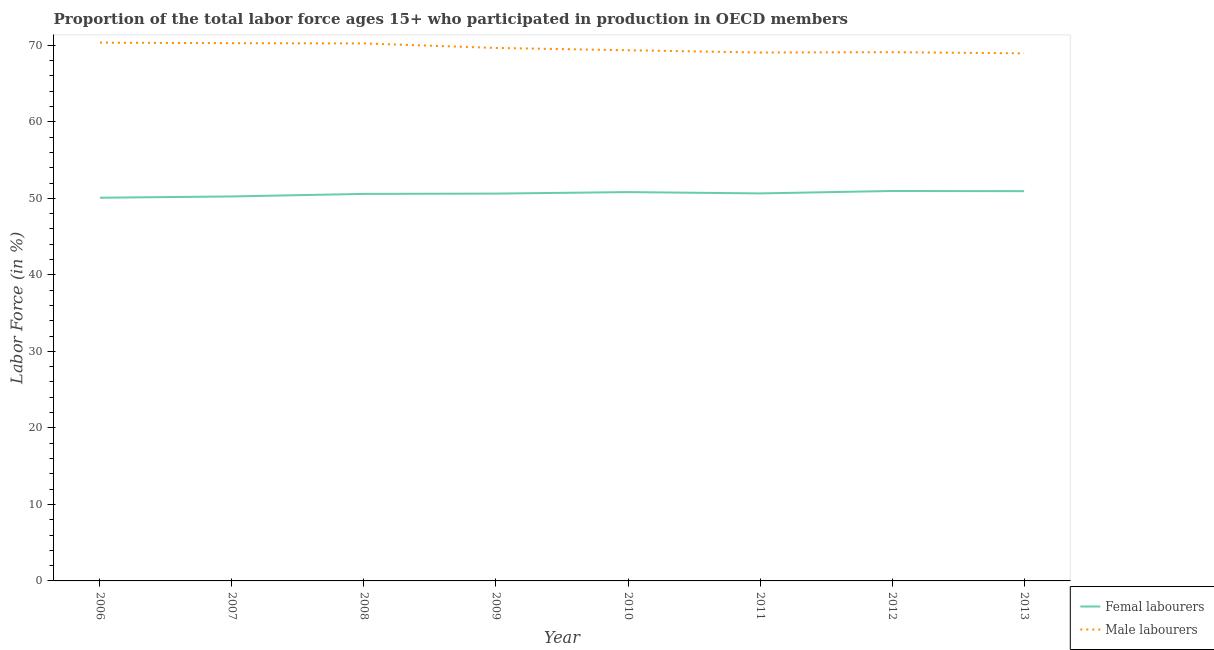How many different coloured lines are there?
Your answer should be very brief. 2. Is the number of lines equal to the number of legend labels?
Give a very brief answer. Yes. What is the percentage of female labor force in 2007?
Provide a short and direct response. 50.25. Across all years, what is the maximum percentage of male labour force?
Your answer should be compact. 70.35. Across all years, what is the minimum percentage of female labor force?
Your answer should be very brief. 50.08. In which year was the percentage of male labour force maximum?
Your answer should be compact. 2006. In which year was the percentage of female labor force minimum?
Your answer should be compact. 2006. What is the total percentage of female labor force in the graph?
Offer a terse response. 404.91. What is the difference between the percentage of male labour force in 2011 and that in 2013?
Your answer should be very brief. 0.11. What is the difference between the percentage of male labour force in 2006 and the percentage of female labor force in 2013?
Offer a terse response. 19.41. What is the average percentage of male labour force per year?
Provide a succinct answer. 69.63. In the year 2008, what is the difference between the percentage of male labour force and percentage of female labor force?
Offer a terse response. 19.67. In how many years, is the percentage of female labor force greater than 20 %?
Offer a terse response. 8. What is the ratio of the percentage of male labour force in 2006 to that in 2011?
Provide a succinct answer. 1.02. Is the percentage of female labor force in 2009 less than that in 2010?
Your response must be concise. Yes. Is the difference between the percentage of female labor force in 2006 and 2008 greater than the difference between the percentage of male labour force in 2006 and 2008?
Your answer should be very brief. No. What is the difference between the highest and the second highest percentage of female labor force?
Provide a short and direct response. 0.03. What is the difference between the highest and the lowest percentage of male labour force?
Your response must be concise. 1.4. In how many years, is the percentage of male labour force greater than the average percentage of male labour force taken over all years?
Offer a terse response. 4. Does the percentage of male labour force monotonically increase over the years?
Offer a terse response. No. Is the percentage of male labour force strictly greater than the percentage of female labor force over the years?
Offer a terse response. Yes. Is the percentage of female labor force strictly less than the percentage of male labour force over the years?
Provide a short and direct response. Yes. How many lines are there?
Keep it short and to the point. 2. How many years are there in the graph?
Offer a very short reply. 8. What is the difference between two consecutive major ticks on the Y-axis?
Give a very brief answer. 10. Are the values on the major ticks of Y-axis written in scientific E-notation?
Your answer should be compact. No. Does the graph contain grids?
Make the answer very short. No. What is the title of the graph?
Your response must be concise. Proportion of the total labor force ages 15+ who participated in production in OECD members. What is the Labor Force (in %) of Femal labourers in 2006?
Provide a short and direct response. 50.08. What is the Labor Force (in %) of Male labourers in 2006?
Your answer should be compact. 70.35. What is the Labor Force (in %) in Femal labourers in 2007?
Your answer should be compact. 50.25. What is the Labor Force (in %) in Male labourers in 2007?
Provide a succinct answer. 70.28. What is the Labor Force (in %) of Femal labourers in 2008?
Offer a very short reply. 50.58. What is the Labor Force (in %) of Male labourers in 2008?
Make the answer very short. 70.25. What is the Labor Force (in %) in Femal labourers in 2009?
Give a very brief answer. 50.62. What is the Labor Force (in %) of Male labourers in 2009?
Your answer should be compact. 69.66. What is the Labor Force (in %) of Femal labourers in 2010?
Your answer should be very brief. 50.82. What is the Labor Force (in %) in Male labourers in 2010?
Keep it short and to the point. 69.36. What is the Labor Force (in %) in Femal labourers in 2011?
Keep it short and to the point. 50.65. What is the Labor Force (in %) in Male labourers in 2011?
Your answer should be compact. 69.06. What is the Labor Force (in %) in Femal labourers in 2012?
Ensure brevity in your answer.  50.96. What is the Labor Force (in %) of Male labourers in 2012?
Your answer should be compact. 69.1. What is the Labor Force (in %) in Femal labourers in 2013?
Your response must be concise. 50.94. What is the Labor Force (in %) in Male labourers in 2013?
Keep it short and to the point. 68.95. Across all years, what is the maximum Labor Force (in %) in Femal labourers?
Ensure brevity in your answer.  50.96. Across all years, what is the maximum Labor Force (in %) in Male labourers?
Provide a succinct answer. 70.35. Across all years, what is the minimum Labor Force (in %) of Femal labourers?
Your response must be concise. 50.08. Across all years, what is the minimum Labor Force (in %) in Male labourers?
Ensure brevity in your answer.  68.95. What is the total Labor Force (in %) of Femal labourers in the graph?
Provide a succinct answer. 404.91. What is the total Labor Force (in %) in Male labourers in the graph?
Your response must be concise. 557.02. What is the difference between the Labor Force (in %) of Femal labourers in 2006 and that in 2007?
Give a very brief answer. -0.17. What is the difference between the Labor Force (in %) of Male labourers in 2006 and that in 2007?
Your answer should be compact. 0.07. What is the difference between the Labor Force (in %) in Femal labourers in 2006 and that in 2008?
Give a very brief answer. -0.5. What is the difference between the Labor Force (in %) in Male labourers in 2006 and that in 2008?
Give a very brief answer. 0.1. What is the difference between the Labor Force (in %) of Femal labourers in 2006 and that in 2009?
Provide a short and direct response. -0.54. What is the difference between the Labor Force (in %) in Male labourers in 2006 and that in 2009?
Offer a terse response. 0.69. What is the difference between the Labor Force (in %) of Femal labourers in 2006 and that in 2010?
Your answer should be very brief. -0.74. What is the difference between the Labor Force (in %) of Male labourers in 2006 and that in 2010?
Your answer should be very brief. 0.99. What is the difference between the Labor Force (in %) of Femal labourers in 2006 and that in 2011?
Give a very brief answer. -0.57. What is the difference between the Labor Force (in %) of Male labourers in 2006 and that in 2011?
Provide a succinct answer. 1.29. What is the difference between the Labor Force (in %) in Femal labourers in 2006 and that in 2012?
Give a very brief answer. -0.88. What is the difference between the Labor Force (in %) in Male labourers in 2006 and that in 2012?
Ensure brevity in your answer.  1.25. What is the difference between the Labor Force (in %) of Femal labourers in 2006 and that in 2013?
Your response must be concise. -0.86. What is the difference between the Labor Force (in %) in Male labourers in 2006 and that in 2013?
Offer a very short reply. 1.4. What is the difference between the Labor Force (in %) of Femal labourers in 2007 and that in 2008?
Your answer should be very brief. -0.33. What is the difference between the Labor Force (in %) of Male labourers in 2007 and that in 2008?
Offer a terse response. 0.03. What is the difference between the Labor Force (in %) of Femal labourers in 2007 and that in 2009?
Give a very brief answer. -0.37. What is the difference between the Labor Force (in %) in Male labourers in 2007 and that in 2009?
Ensure brevity in your answer.  0.62. What is the difference between the Labor Force (in %) of Femal labourers in 2007 and that in 2010?
Offer a very short reply. -0.57. What is the difference between the Labor Force (in %) of Male labourers in 2007 and that in 2010?
Ensure brevity in your answer.  0.92. What is the difference between the Labor Force (in %) of Femal labourers in 2007 and that in 2011?
Provide a short and direct response. -0.4. What is the difference between the Labor Force (in %) in Male labourers in 2007 and that in 2011?
Provide a short and direct response. 1.22. What is the difference between the Labor Force (in %) in Femal labourers in 2007 and that in 2012?
Provide a short and direct response. -0.71. What is the difference between the Labor Force (in %) in Male labourers in 2007 and that in 2012?
Offer a terse response. 1.18. What is the difference between the Labor Force (in %) of Femal labourers in 2007 and that in 2013?
Offer a terse response. -0.69. What is the difference between the Labor Force (in %) in Male labourers in 2007 and that in 2013?
Ensure brevity in your answer.  1.33. What is the difference between the Labor Force (in %) in Femal labourers in 2008 and that in 2009?
Provide a short and direct response. -0.04. What is the difference between the Labor Force (in %) in Male labourers in 2008 and that in 2009?
Give a very brief answer. 0.59. What is the difference between the Labor Force (in %) of Femal labourers in 2008 and that in 2010?
Your answer should be compact. -0.23. What is the difference between the Labor Force (in %) of Male labourers in 2008 and that in 2010?
Your response must be concise. 0.89. What is the difference between the Labor Force (in %) in Femal labourers in 2008 and that in 2011?
Give a very brief answer. -0.06. What is the difference between the Labor Force (in %) in Male labourers in 2008 and that in 2011?
Provide a short and direct response. 1.19. What is the difference between the Labor Force (in %) of Femal labourers in 2008 and that in 2012?
Provide a succinct answer. -0.38. What is the difference between the Labor Force (in %) of Male labourers in 2008 and that in 2012?
Give a very brief answer. 1.15. What is the difference between the Labor Force (in %) of Femal labourers in 2008 and that in 2013?
Offer a very short reply. -0.35. What is the difference between the Labor Force (in %) in Male labourers in 2008 and that in 2013?
Keep it short and to the point. 1.3. What is the difference between the Labor Force (in %) of Femal labourers in 2009 and that in 2010?
Offer a terse response. -0.2. What is the difference between the Labor Force (in %) of Male labourers in 2009 and that in 2010?
Give a very brief answer. 0.3. What is the difference between the Labor Force (in %) in Femal labourers in 2009 and that in 2011?
Provide a succinct answer. -0.02. What is the difference between the Labor Force (in %) of Male labourers in 2009 and that in 2011?
Offer a terse response. 0.6. What is the difference between the Labor Force (in %) in Femal labourers in 2009 and that in 2012?
Your answer should be compact. -0.34. What is the difference between the Labor Force (in %) in Male labourers in 2009 and that in 2012?
Give a very brief answer. 0.55. What is the difference between the Labor Force (in %) of Femal labourers in 2009 and that in 2013?
Make the answer very short. -0.32. What is the difference between the Labor Force (in %) of Male labourers in 2009 and that in 2013?
Keep it short and to the point. 0.71. What is the difference between the Labor Force (in %) in Femal labourers in 2010 and that in 2011?
Your answer should be compact. 0.17. What is the difference between the Labor Force (in %) in Male labourers in 2010 and that in 2011?
Ensure brevity in your answer.  0.3. What is the difference between the Labor Force (in %) of Femal labourers in 2010 and that in 2012?
Make the answer very short. -0.15. What is the difference between the Labor Force (in %) of Male labourers in 2010 and that in 2012?
Your answer should be compact. 0.25. What is the difference between the Labor Force (in %) in Femal labourers in 2010 and that in 2013?
Make the answer very short. -0.12. What is the difference between the Labor Force (in %) in Male labourers in 2010 and that in 2013?
Make the answer very short. 0.41. What is the difference between the Labor Force (in %) in Femal labourers in 2011 and that in 2012?
Offer a very short reply. -0.32. What is the difference between the Labor Force (in %) of Male labourers in 2011 and that in 2012?
Keep it short and to the point. -0.04. What is the difference between the Labor Force (in %) of Femal labourers in 2011 and that in 2013?
Offer a terse response. -0.29. What is the difference between the Labor Force (in %) of Male labourers in 2011 and that in 2013?
Provide a short and direct response. 0.11. What is the difference between the Labor Force (in %) of Femal labourers in 2012 and that in 2013?
Provide a short and direct response. 0.03. What is the difference between the Labor Force (in %) in Male labourers in 2012 and that in 2013?
Your answer should be very brief. 0.15. What is the difference between the Labor Force (in %) in Femal labourers in 2006 and the Labor Force (in %) in Male labourers in 2007?
Give a very brief answer. -20.2. What is the difference between the Labor Force (in %) of Femal labourers in 2006 and the Labor Force (in %) of Male labourers in 2008?
Offer a terse response. -20.17. What is the difference between the Labor Force (in %) of Femal labourers in 2006 and the Labor Force (in %) of Male labourers in 2009?
Offer a terse response. -19.58. What is the difference between the Labor Force (in %) of Femal labourers in 2006 and the Labor Force (in %) of Male labourers in 2010?
Ensure brevity in your answer.  -19.28. What is the difference between the Labor Force (in %) in Femal labourers in 2006 and the Labor Force (in %) in Male labourers in 2011?
Your answer should be compact. -18.98. What is the difference between the Labor Force (in %) in Femal labourers in 2006 and the Labor Force (in %) in Male labourers in 2012?
Ensure brevity in your answer.  -19.02. What is the difference between the Labor Force (in %) in Femal labourers in 2006 and the Labor Force (in %) in Male labourers in 2013?
Your response must be concise. -18.87. What is the difference between the Labor Force (in %) of Femal labourers in 2007 and the Labor Force (in %) of Male labourers in 2008?
Provide a short and direct response. -20. What is the difference between the Labor Force (in %) of Femal labourers in 2007 and the Labor Force (in %) of Male labourers in 2009?
Offer a very short reply. -19.41. What is the difference between the Labor Force (in %) of Femal labourers in 2007 and the Labor Force (in %) of Male labourers in 2010?
Make the answer very short. -19.11. What is the difference between the Labor Force (in %) in Femal labourers in 2007 and the Labor Force (in %) in Male labourers in 2011?
Provide a succinct answer. -18.81. What is the difference between the Labor Force (in %) of Femal labourers in 2007 and the Labor Force (in %) of Male labourers in 2012?
Provide a short and direct response. -18.85. What is the difference between the Labor Force (in %) in Femal labourers in 2007 and the Labor Force (in %) in Male labourers in 2013?
Offer a terse response. -18.7. What is the difference between the Labor Force (in %) in Femal labourers in 2008 and the Labor Force (in %) in Male labourers in 2009?
Give a very brief answer. -19.07. What is the difference between the Labor Force (in %) of Femal labourers in 2008 and the Labor Force (in %) of Male labourers in 2010?
Your answer should be compact. -18.77. What is the difference between the Labor Force (in %) in Femal labourers in 2008 and the Labor Force (in %) in Male labourers in 2011?
Your answer should be compact. -18.48. What is the difference between the Labor Force (in %) of Femal labourers in 2008 and the Labor Force (in %) of Male labourers in 2012?
Give a very brief answer. -18.52. What is the difference between the Labor Force (in %) in Femal labourers in 2008 and the Labor Force (in %) in Male labourers in 2013?
Provide a short and direct response. -18.37. What is the difference between the Labor Force (in %) in Femal labourers in 2009 and the Labor Force (in %) in Male labourers in 2010?
Make the answer very short. -18.74. What is the difference between the Labor Force (in %) of Femal labourers in 2009 and the Labor Force (in %) of Male labourers in 2011?
Your response must be concise. -18.44. What is the difference between the Labor Force (in %) of Femal labourers in 2009 and the Labor Force (in %) of Male labourers in 2012?
Ensure brevity in your answer.  -18.48. What is the difference between the Labor Force (in %) in Femal labourers in 2009 and the Labor Force (in %) in Male labourers in 2013?
Keep it short and to the point. -18.33. What is the difference between the Labor Force (in %) in Femal labourers in 2010 and the Labor Force (in %) in Male labourers in 2011?
Give a very brief answer. -18.24. What is the difference between the Labor Force (in %) of Femal labourers in 2010 and the Labor Force (in %) of Male labourers in 2012?
Offer a terse response. -18.29. What is the difference between the Labor Force (in %) in Femal labourers in 2010 and the Labor Force (in %) in Male labourers in 2013?
Give a very brief answer. -18.13. What is the difference between the Labor Force (in %) of Femal labourers in 2011 and the Labor Force (in %) of Male labourers in 2012?
Provide a succinct answer. -18.46. What is the difference between the Labor Force (in %) of Femal labourers in 2011 and the Labor Force (in %) of Male labourers in 2013?
Give a very brief answer. -18.3. What is the difference between the Labor Force (in %) in Femal labourers in 2012 and the Labor Force (in %) in Male labourers in 2013?
Keep it short and to the point. -17.99. What is the average Labor Force (in %) of Femal labourers per year?
Your answer should be compact. 50.61. What is the average Labor Force (in %) in Male labourers per year?
Make the answer very short. 69.63. In the year 2006, what is the difference between the Labor Force (in %) of Femal labourers and Labor Force (in %) of Male labourers?
Offer a terse response. -20.27. In the year 2007, what is the difference between the Labor Force (in %) of Femal labourers and Labor Force (in %) of Male labourers?
Give a very brief answer. -20.03. In the year 2008, what is the difference between the Labor Force (in %) in Femal labourers and Labor Force (in %) in Male labourers?
Provide a short and direct response. -19.67. In the year 2009, what is the difference between the Labor Force (in %) in Femal labourers and Labor Force (in %) in Male labourers?
Offer a terse response. -19.04. In the year 2010, what is the difference between the Labor Force (in %) in Femal labourers and Labor Force (in %) in Male labourers?
Provide a short and direct response. -18.54. In the year 2011, what is the difference between the Labor Force (in %) of Femal labourers and Labor Force (in %) of Male labourers?
Your answer should be very brief. -18.41. In the year 2012, what is the difference between the Labor Force (in %) in Femal labourers and Labor Force (in %) in Male labourers?
Keep it short and to the point. -18.14. In the year 2013, what is the difference between the Labor Force (in %) of Femal labourers and Labor Force (in %) of Male labourers?
Offer a terse response. -18.01. What is the ratio of the Labor Force (in %) of Male labourers in 2006 to that in 2007?
Provide a short and direct response. 1. What is the ratio of the Labor Force (in %) in Femal labourers in 2006 to that in 2008?
Your response must be concise. 0.99. What is the ratio of the Labor Force (in %) of Femal labourers in 2006 to that in 2009?
Your answer should be compact. 0.99. What is the ratio of the Labor Force (in %) in Male labourers in 2006 to that in 2009?
Ensure brevity in your answer.  1.01. What is the ratio of the Labor Force (in %) in Femal labourers in 2006 to that in 2010?
Make the answer very short. 0.99. What is the ratio of the Labor Force (in %) in Male labourers in 2006 to that in 2010?
Keep it short and to the point. 1.01. What is the ratio of the Labor Force (in %) of Femal labourers in 2006 to that in 2011?
Provide a succinct answer. 0.99. What is the ratio of the Labor Force (in %) of Male labourers in 2006 to that in 2011?
Ensure brevity in your answer.  1.02. What is the ratio of the Labor Force (in %) of Femal labourers in 2006 to that in 2012?
Offer a terse response. 0.98. What is the ratio of the Labor Force (in %) of Male labourers in 2006 to that in 2012?
Ensure brevity in your answer.  1.02. What is the ratio of the Labor Force (in %) in Femal labourers in 2006 to that in 2013?
Your answer should be very brief. 0.98. What is the ratio of the Labor Force (in %) in Male labourers in 2006 to that in 2013?
Offer a very short reply. 1.02. What is the ratio of the Labor Force (in %) of Femal labourers in 2007 to that in 2008?
Provide a short and direct response. 0.99. What is the ratio of the Labor Force (in %) in Femal labourers in 2007 to that in 2009?
Ensure brevity in your answer.  0.99. What is the ratio of the Labor Force (in %) of Male labourers in 2007 to that in 2009?
Ensure brevity in your answer.  1.01. What is the ratio of the Labor Force (in %) in Male labourers in 2007 to that in 2010?
Give a very brief answer. 1.01. What is the ratio of the Labor Force (in %) of Femal labourers in 2007 to that in 2011?
Your answer should be very brief. 0.99. What is the ratio of the Labor Force (in %) in Male labourers in 2007 to that in 2011?
Make the answer very short. 1.02. What is the ratio of the Labor Force (in %) of Femal labourers in 2007 to that in 2012?
Provide a succinct answer. 0.99. What is the ratio of the Labor Force (in %) in Femal labourers in 2007 to that in 2013?
Ensure brevity in your answer.  0.99. What is the ratio of the Labor Force (in %) in Male labourers in 2007 to that in 2013?
Offer a terse response. 1.02. What is the ratio of the Labor Force (in %) in Femal labourers in 2008 to that in 2009?
Your answer should be compact. 1. What is the ratio of the Labor Force (in %) of Male labourers in 2008 to that in 2009?
Make the answer very short. 1.01. What is the ratio of the Labor Force (in %) of Femal labourers in 2008 to that in 2010?
Ensure brevity in your answer.  1. What is the ratio of the Labor Force (in %) in Male labourers in 2008 to that in 2010?
Ensure brevity in your answer.  1.01. What is the ratio of the Labor Force (in %) of Femal labourers in 2008 to that in 2011?
Keep it short and to the point. 1. What is the ratio of the Labor Force (in %) in Male labourers in 2008 to that in 2011?
Keep it short and to the point. 1.02. What is the ratio of the Labor Force (in %) in Femal labourers in 2008 to that in 2012?
Your response must be concise. 0.99. What is the ratio of the Labor Force (in %) in Male labourers in 2008 to that in 2012?
Keep it short and to the point. 1.02. What is the ratio of the Labor Force (in %) in Male labourers in 2008 to that in 2013?
Keep it short and to the point. 1.02. What is the ratio of the Labor Force (in %) of Male labourers in 2009 to that in 2011?
Provide a short and direct response. 1.01. What is the ratio of the Labor Force (in %) of Femal labourers in 2009 to that in 2012?
Keep it short and to the point. 0.99. What is the ratio of the Labor Force (in %) of Male labourers in 2009 to that in 2012?
Make the answer very short. 1.01. What is the ratio of the Labor Force (in %) of Femal labourers in 2009 to that in 2013?
Provide a short and direct response. 0.99. What is the ratio of the Labor Force (in %) of Male labourers in 2009 to that in 2013?
Offer a very short reply. 1.01. What is the ratio of the Labor Force (in %) of Male labourers in 2010 to that in 2012?
Provide a succinct answer. 1. What is the ratio of the Labor Force (in %) in Male labourers in 2010 to that in 2013?
Ensure brevity in your answer.  1.01. What is the ratio of the Labor Force (in %) in Femal labourers in 2011 to that in 2012?
Your answer should be very brief. 0.99. What is the ratio of the Labor Force (in %) of Male labourers in 2011 to that in 2012?
Provide a short and direct response. 1. What is the ratio of the Labor Force (in %) of Femal labourers in 2011 to that in 2013?
Your response must be concise. 0.99. What is the ratio of the Labor Force (in %) of Femal labourers in 2012 to that in 2013?
Ensure brevity in your answer.  1. What is the difference between the highest and the second highest Labor Force (in %) in Femal labourers?
Give a very brief answer. 0.03. What is the difference between the highest and the second highest Labor Force (in %) in Male labourers?
Your answer should be very brief. 0.07. What is the difference between the highest and the lowest Labor Force (in %) in Femal labourers?
Your answer should be very brief. 0.88. What is the difference between the highest and the lowest Labor Force (in %) of Male labourers?
Give a very brief answer. 1.4. 